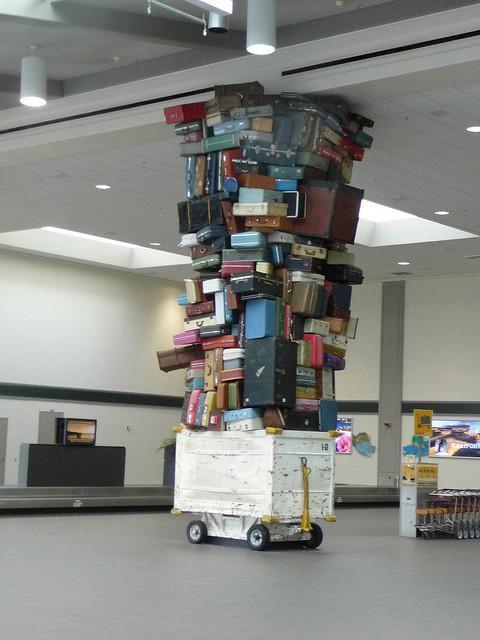How many wheels are on the luggage?
Give a very brief answer. 4. How many suitcases are in the picture?
Give a very brief answer. 2. How many bikes are?
Give a very brief answer. 0. 